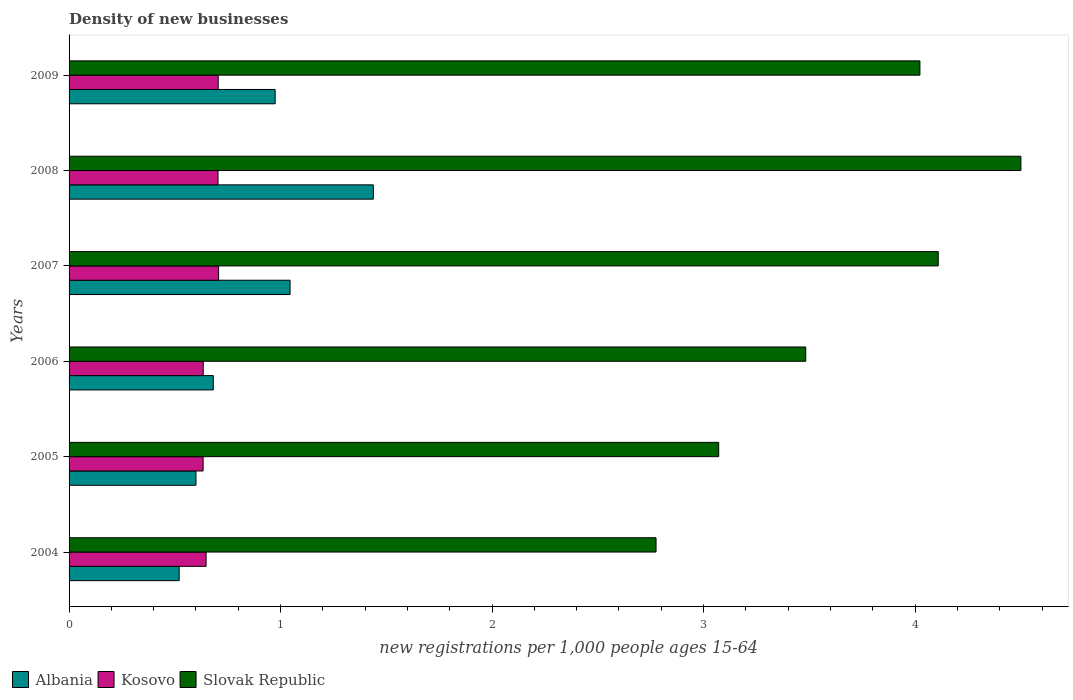How many different coloured bars are there?
Offer a very short reply. 3. How many bars are there on the 5th tick from the top?
Offer a terse response. 3. What is the label of the 4th group of bars from the top?
Offer a very short reply. 2006. In how many cases, is the number of bars for a given year not equal to the number of legend labels?
Your answer should be very brief. 0. What is the number of new registrations in Albania in 2007?
Provide a succinct answer. 1.04. Across all years, what is the maximum number of new registrations in Kosovo?
Offer a terse response. 0.71. Across all years, what is the minimum number of new registrations in Slovak Republic?
Your answer should be compact. 2.78. In which year was the number of new registrations in Albania maximum?
Provide a succinct answer. 2008. What is the total number of new registrations in Kosovo in the graph?
Ensure brevity in your answer.  4.03. What is the difference between the number of new registrations in Slovak Republic in 2004 and that in 2005?
Your answer should be compact. -0.3. What is the difference between the number of new registrations in Kosovo in 2004 and the number of new registrations in Albania in 2009?
Provide a succinct answer. -0.33. What is the average number of new registrations in Slovak Republic per year?
Provide a succinct answer. 3.66. In the year 2007, what is the difference between the number of new registrations in Albania and number of new registrations in Kosovo?
Offer a terse response. 0.34. In how many years, is the number of new registrations in Albania greater than 3 ?
Keep it short and to the point. 0. What is the ratio of the number of new registrations in Kosovo in 2005 to that in 2006?
Keep it short and to the point. 1. Is the number of new registrations in Kosovo in 2008 less than that in 2009?
Offer a very short reply. Yes. Is the difference between the number of new registrations in Albania in 2004 and 2009 greater than the difference between the number of new registrations in Kosovo in 2004 and 2009?
Your answer should be compact. No. What is the difference between the highest and the second highest number of new registrations in Albania?
Your response must be concise. 0.39. What is the difference between the highest and the lowest number of new registrations in Albania?
Your answer should be compact. 0.92. What does the 1st bar from the top in 2009 represents?
Keep it short and to the point. Slovak Republic. What does the 1st bar from the bottom in 2008 represents?
Give a very brief answer. Albania. What is the difference between two consecutive major ticks on the X-axis?
Your answer should be very brief. 1. Where does the legend appear in the graph?
Your answer should be very brief. Bottom left. How are the legend labels stacked?
Provide a short and direct response. Horizontal. What is the title of the graph?
Your response must be concise. Density of new businesses. What is the label or title of the X-axis?
Offer a very short reply. New registrations per 1,0 people ages 15-64. What is the label or title of the Y-axis?
Offer a very short reply. Years. What is the new registrations per 1,000 people ages 15-64 in Albania in 2004?
Provide a short and direct response. 0.52. What is the new registrations per 1,000 people ages 15-64 of Kosovo in 2004?
Provide a succinct answer. 0.65. What is the new registrations per 1,000 people ages 15-64 in Slovak Republic in 2004?
Ensure brevity in your answer.  2.78. What is the new registrations per 1,000 people ages 15-64 of Albania in 2005?
Keep it short and to the point. 0.6. What is the new registrations per 1,000 people ages 15-64 in Kosovo in 2005?
Your answer should be very brief. 0.63. What is the new registrations per 1,000 people ages 15-64 in Slovak Republic in 2005?
Provide a short and direct response. 3.07. What is the new registrations per 1,000 people ages 15-64 in Albania in 2006?
Provide a short and direct response. 0.68. What is the new registrations per 1,000 people ages 15-64 in Kosovo in 2006?
Your response must be concise. 0.63. What is the new registrations per 1,000 people ages 15-64 of Slovak Republic in 2006?
Your response must be concise. 3.48. What is the new registrations per 1,000 people ages 15-64 of Albania in 2007?
Provide a succinct answer. 1.04. What is the new registrations per 1,000 people ages 15-64 of Kosovo in 2007?
Your response must be concise. 0.71. What is the new registrations per 1,000 people ages 15-64 of Slovak Republic in 2007?
Provide a succinct answer. 4.11. What is the new registrations per 1,000 people ages 15-64 in Albania in 2008?
Offer a very short reply. 1.44. What is the new registrations per 1,000 people ages 15-64 in Kosovo in 2008?
Give a very brief answer. 0.7. What is the new registrations per 1,000 people ages 15-64 in Slovak Republic in 2008?
Give a very brief answer. 4.5. What is the new registrations per 1,000 people ages 15-64 of Albania in 2009?
Provide a short and direct response. 0.97. What is the new registrations per 1,000 people ages 15-64 in Kosovo in 2009?
Make the answer very short. 0.7. What is the new registrations per 1,000 people ages 15-64 of Slovak Republic in 2009?
Your answer should be compact. 4.02. Across all years, what is the maximum new registrations per 1,000 people ages 15-64 in Albania?
Make the answer very short. 1.44. Across all years, what is the maximum new registrations per 1,000 people ages 15-64 in Kosovo?
Your response must be concise. 0.71. Across all years, what is the maximum new registrations per 1,000 people ages 15-64 in Slovak Republic?
Your response must be concise. 4.5. Across all years, what is the minimum new registrations per 1,000 people ages 15-64 of Albania?
Your answer should be compact. 0.52. Across all years, what is the minimum new registrations per 1,000 people ages 15-64 of Kosovo?
Ensure brevity in your answer.  0.63. Across all years, what is the minimum new registrations per 1,000 people ages 15-64 of Slovak Republic?
Provide a short and direct response. 2.78. What is the total new registrations per 1,000 people ages 15-64 of Albania in the graph?
Your response must be concise. 5.26. What is the total new registrations per 1,000 people ages 15-64 in Kosovo in the graph?
Your answer should be compact. 4.03. What is the total new registrations per 1,000 people ages 15-64 of Slovak Republic in the graph?
Provide a succinct answer. 21.96. What is the difference between the new registrations per 1,000 people ages 15-64 of Albania in 2004 and that in 2005?
Offer a very short reply. -0.08. What is the difference between the new registrations per 1,000 people ages 15-64 of Kosovo in 2004 and that in 2005?
Ensure brevity in your answer.  0.01. What is the difference between the new registrations per 1,000 people ages 15-64 in Slovak Republic in 2004 and that in 2005?
Offer a terse response. -0.3. What is the difference between the new registrations per 1,000 people ages 15-64 in Albania in 2004 and that in 2006?
Offer a very short reply. -0.16. What is the difference between the new registrations per 1,000 people ages 15-64 in Kosovo in 2004 and that in 2006?
Ensure brevity in your answer.  0.01. What is the difference between the new registrations per 1,000 people ages 15-64 of Slovak Republic in 2004 and that in 2006?
Your answer should be compact. -0.71. What is the difference between the new registrations per 1,000 people ages 15-64 of Albania in 2004 and that in 2007?
Your answer should be compact. -0.52. What is the difference between the new registrations per 1,000 people ages 15-64 in Kosovo in 2004 and that in 2007?
Offer a terse response. -0.06. What is the difference between the new registrations per 1,000 people ages 15-64 of Slovak Republic in 2004 and that in 2007?
Provide a short and direct response. -1.33. What is the difference between the new registrations per 1,000 people ages 15-64 of Albania in 2004 and that in 2008?
Ensure brevity in your answer.  -0.92. What is the difference between the new registrations per 1,000 people ages 15-64 of Kosovo in 2004 and that in 2008?
Provide a succinct answer. -0.06. What is the difference between the new registrations per 1,000 people ages 15-64 in Slovak Republic in 2004 and that in 2008?
Your answer should be very brief. -1.73. What is the difference between the new registrations per 1,000 people ages 15-64 of Albania in 2004 and that in 2009?
Ensure brevity in your answer.  -0.45. What is the difference between the new registrations per 1,000 people ages 15-64 of Kosovo in 2004 and that in 2009?
Provide a succinct answer. -0.06. What is the difference between the new registrations per 1,000 people ages 15-64 in Slovak Republic in 2004 and that in 2009?
Offer a terse response. -1.25. What is the difference between the new registrations per 1,000 people ages 15-64 in Albania in 2005 and that in 2006?
Offer a terse response. -0.08. What is the difference between the new registrations per 1,000 people ages 15-64 in Kosovo in 2005 and that in 2006?
Ensure brevity in your answer.  -0. What is the difference between the new registrations per 1,000 people ages 15-64 of Slovak Republic in 2005 and that in 2006?
Keep it short and to the point. -0.41. What is the difference between the new registrations per 1,000 people ages 15-64 in Albania in 2005 and that in 2007?
Keep it short and to the point. -0.45. What is the difference between the new registrations per 1,000 people ages 15-64 of Kosovo in 2005 and that in 2007?
Your response must be concise. -0.07. What is the difference between the new registrations per 1,000 people ages 15-64 in Slovak Republic in 2005 and that in 2007?
Give a very brief answer. -1.04. What is the difference between the new registrations per 1,000 people ages 15-64 in Albania in 2005 and that in 2008?
Your answer should be compact. -0.84. What is the difference between the new registrations per 1,000 people ages 15-64 of Kosovo in 2005 and that in 2008?
Keep it short and to the point. -0.07. What is the difference between the new registrations per 1,000 people ages 15-64 in Slovak Republic in 2005 and that in 2008?
Ensure brevity in your answer.  -1.43. What is the difference between the new registrations per 1,000 people ages 15-64 in Albania in 2005 and that in 2009?
Keep it short and to the point. -0.37. What is the difference between the new registrations per 1,000 people ages 15-64 in Kosovo in 2005 and that in 2009?
Ensure brevity in your answer.  -0.07. What is the difference between the new registrations per 1,000 people ages 15-64 in Slovak Republic in 2005 and that in 2009?
Provide a succinct answer. -0.95. What is the difference between the new registrations per 1,000 people ages 15-64 of Albania in 2006 and that in 2007?
Offer a very short reply. -0.36. What is the difference between the new registrations per 1,000 people ages 15-64 of Kosovo in 2006 and that in 2007?
Provide a short and direct response. -0.07. What is the difference between the new registrations per 1,000 people ages 15-64 in Slovak Republic in 2006 and that in 2007?
Provide a short and direct response. -0.63. What is the difference between the new registrations per 1,000 people ages 15-64 in Albania in 2006 and that in 2008?
Ensure brevity in your answer.  -0.76. What is the difference between the new registrations per 1,000 people ages 15-64 of Kosovo in 2006 and that in 2008?
Offer a terse response. -0.07. What is the difference between the new registrations per 1,000 people ages 15-64 in Slovak Republic in 2006 and that in 2008?
Your answer should be very brief. -1.02. What is the difference between the new registrations per 1,000 people ages 15-64 in Albania in 2006 and that in 2009?
Offer a very short reply. -0.29. What is the difference between the new registrations per 1,000 people ages 15-64 of Kosovo in 2006 and that in 2009?
Your answer should be compact. -0.07. What is the difference between the new registrations per 1,000 people ages 15-64 of Slovak Republic in 2006 and that in 2009?
Make the answer very short. -0.54. What is the difference between the new registrations per 1,000 people ages 15-64 of Albania in 2007 and that in 2008?
Your answer should be compact. -0.39. What is the difference between the new registrations per 1,000 people ages 15-64 of Kosovo in 2007 and that in 2008?
Keep it short and to the point. 0. What is the difference between the new registrations per 1,000 people ages 15-64 of Slovak Republic in 2007 and that in 2008?
Ensure brevity in your answer.  -0.39. What is the difference between the new registrations per 1,000 people ages 15-64 of Albania in 2007 and that in 2009?
Keep it short and to the point. 0.07. What is the difference between the new registrations per 1,000 people ages 15-64 of Kosovo in 2007 and that in 2009?
Give a very brief answer. 0. What is the difference between the new registrations per 1,000 people ages 15-64 of Slovak Republic in 2007 and that in 2009?
Provide a succinct answer. 0.09. What is the difference between the new registrations per 1,000 people ages 15-64 in Albania in 2008 and that in 2009?
Keep it short and to the point. 0.46. What is the difference between the new registrations per 1,000 people ages 15-64 of Kosovo in 2008 and that in 2009?
Your answer should be very brief. -0. What is the difference between the new registrations per 1,000 people ages 15-64 of Slovak Republic in 2008 and that in 2009?
Provide a short and direct response. 0.48. What is the difference between the new registrations per 1,000 people ages 15-64 of Albania in 2004 and the new registrations per 1,000 people ages 15-64 of Kosovo in 2005?
Give a very brief answer. -0.11. What is the difference between the new registrations per 1,000 people ages 15-64 in Albania in 2004 and the new registrations per 1,000 people ages 15-64 in Slovak Republic in 2005?
Give a very brief answer. -2.55. What is the difference between the new registrations per 1,000 people ages 15-64 of Kosovo in 2004 and the new registrations per 1,000 people ages 15-64 of Slovak Republic in 2005?
Provide a short and direct response. -2.42. What is the difference between the new registrations per 1,000 people ages 15-64 of Albania in 2004 and the new registrations per 1,000 people ages 15-64 of Kosovo in 2006?
Make the answer very short. -0.11. What is the difference between the new registrations per 1,000 people ages 15-64 of Albania in 2004 and the new registrations per 1,000 people ages 15-64 of Slovak Republic in 2006?
Keep it short and to the point. -2.96. What is the difference between the new registrations per 1,000 people ages 15-64 in Kosovo in 2004 and the new registrations per 1,000 people ages 15-64 in Slovak Republic in 2006?
Offer a terse response. -2.84. What is the difference between the new registrations per 1,000 people ages 15-64 in Albania in 2004 and the new registrations per 1,000 people ages 15-64 in Kosovo in 2007?
Keep it short and to the point. -0.19. What is the difference between the new registrations per 1,000 people ages 15-64 of Albania in 2004 and the new registrations per 1,000 people ages 15-64 of Slovak Republic in 2007?
Your answer should be very brief. -3.59. What is the difference between the new registrations per 1,000 people ages 15-64 in Kosovo in 2004 and the new registrations per 1,000 people ages 15-64 in Slovak Republic in 2007?
Provide a short and direct response. -3.46. What is the difference between the new registrations per 1,000 people ages 15-64 in Albania in 2004 and the new registrations per 1,000 people ages 15-64 in Kosovo in 2008?
Ensure brevity in your answer.  -0.18. What is the difference between the new registrations per 1,000 people ages 15-64 in Albania in 2004 and the new registrations per 1,000 people ages 15-64 in Slovak Republic in 2008?
Your response must be concise. -3.98. What is the difference between the new registrations per 1,000 people ages 15-64 of Kosovo in 2004 and the new registrations per 1,000 people ages 15-64 of Slovak Republic in 2008?
Provide a short and direct response. -3.85. What is the difference between the new registrations per 1,000 people ages 15-64 of Albania in 2004 and the new registrations per 1,000 people ages 15-64 of Kosovo in 2009?
Keep it short and to the point. -0.18. What is the difference between the new registrations per 1,000 people ages 15-64 in Albania in 2004 and the new registrations per 1,000 people ages 15-64 in Slovak Republic in 2009?
Your response must be concise. -3.5. What is the difference between the new registrations per 1,000 people ages 15-64 of Kosovo in 2004 and the new registrations per 1,000 people ages 15-64 of Slovak Republic in 2009?
Offer a very short reply. -3.38. What is the difference between the new registrations per 1,000 people ages 15-64 in Albania in 2005 and the new registrations per 1,000 people ages 15-64 in Kosovo in 2006?
Give a very brief answer. -0.03. What is the difference between the new registrations per 1,000 people ages 15-64 of Albania in 2005 and the new registrations per 1,000 people ages 15-64 of Slovak Republic in 2006?
Make the answer very short. -2.88. What is the difference between the new registrations per 1,000 people ages 15-64 of Kosovo in 2005 and the new registrations per 1,000 people ages 15-64 of Slovak Republic in 2006?
Your answer should be compact. -2.85. What is the difference between the new registrations per 1,000 people ages 15-64 in Albania in 2005 and the new registrations per 1,000 people ages 15-64 in Kosovo in 2007?
Your answer should be very brief. -0.11. What is the difference between the new registrations per 1,000 people ages 15-64 of Albania in 2005 and the new registrations per 1,000 people ages 15-64 of Slovak Republic in 2007?
Provide a short and direct response. -3.51. What is the difference between the new registrations per 1,000 people ages 15-64 of Kosovo in 2005 and the new registrations per 1,000 people ages 15-64 of Slovak Republic in 2007?
Provide a succinct answer. -3.48. What is the difference between the new registrations per 1,000 people ages 15-64 in Albania in 2005 and the new registrations per 1,000 people ages 15-64 in Kosovo in 2008?
Offer a very short reply. -0.1. What is the difference between the new registrations per 1,000 people ages 15-64 of Albania in 2005 and the new registrations per 1,000 people ages 15-64 of Slovak Republic in 2008?
Provide a short and direct response. -3.9. What is the difference between the new registrations per 1,000 people ages 15-64 in Kosovo in 2005 and the new registrations per 1,000 people ages 15-64 in Slovak Republic in 2008?
Make the answer very short. -3.87. What is the difference between the new registrations per 1,000 people ages 15-64 of Albania in 2005 and the new registrations per 1,000 people ages 15-64 of Kosovo in 2009?
Your answer should be compact. -0.11. What is the difference between the new registrations per 1,000 people ages 15-64 in Albania in 2005 and the new registrations per 1,000 people ages 15-64 in Slovak Republic in 2009?
Your response must be concise. -3.42. What is the difference between the new registrations per 1,000 people ages 15-64 in Kosovo in 2005 and the new registrations per 1,000 people ages 15-64 in Slovak Republic in 2009?
Ensure brevity in your answer.  -3.39. What is the difference between the new registrations per 1,000 people ages 15-64 of Albania in 2006 and the new registrations per 1,000 people ages 15-64 of Kosovo in 2007?
Offer a terse response. -0.03. What is the difference between the new registrations per 1,000 people ages 15-64 in Albania in 2006 and the new registrations per 1,000 people ages 15-64 in Slovak Republic in 2007?
Provide a short and direct response. -3.43. What is the difference between the new registrations per 1,000 people ages 15-64 in Kosovo in 2006 and the new registrations per 1,000 people ages 15-64 in Slovak Republic in 2007?
Make the answer very short. -3.48. What is the difference between the new registrations per 1,000 people ages 15-64 in Albania in 2006 and the new registrations per 1,000 people ages 15-64 in Kosovo in 2008?
Provide a short and direct response. -0.02. What is the difference between the new registrations per 1,000 people ages 15-64 in Albania in 2006 and the new registrations per 1,000 people ages 15-64 in Slovak Republic in 2008?
Ensure brevity in your answer.  -3.82. What is the difference between the new registrations per 1,000 people ages 15-64 in Kosovo in 2006 and the new registrations per 1,000 people ages 15-64 in Slovak Republic in 2008?
Your answer should be very brief. -3.87. What is the difference between the new registrations per 1,000 people ages 15-64 of Albania in 2006 and the new registrations per 1,000 people ages 15-64 of Kosovo in 2009?
Provide a short and direct response. -0.02. What is the difference between the new registrations per 1,000 people ages 15-64 of Albania in 2006 and the new registrations per 1,000 people ages 15-64 of Slovak Republic in 2009?
Your response must be concise. -3.34. What is the difference between the new registrations per 1,000 people ages 15-64 in Kosovo in 2006 and the new registrations per 1,000 people ages 15-64 in Slovak Republic in 2009?
Provide a short and direct response. -3.39. What is the difference between the new registrations per 1,000 people ages 15-64 in Albania in 2007 and the new registrations per 1,000 people ages 15-64 in Kosovo in 2008?
Give a very brief answer. 0.34. What is the difference between the new registrations per 1,000 people ages 15-64 of Albania in 2007 and the new registrations per 1,000 people ages 15-64 of Slovak Republic in 2008?
Provide a succinct answer. -3.46. What is the difference between the new registrations per 1,000 people ages 15-64 in Kosovo in 2007 and the new registrations per 1,000 people ages 15-64 in Slovak Republic in 2008?
Your answer should be compact. -3.79. What is the difference between the new registrations per 1,000 people ages 15-64 in Albania in 2007 and the new registrations per 1,000 people ages 15-64 in Kosovo in 2009?
Ensure brevity in your answer.  0.34. What is the difference between the new registrations per 1,000 people ages 15-64 of Albania in 2007 and the new registrations per 1,000 people ages 15-64 of Slovak Republic in 2009?
Provide a short and direct response. -2.98. What is the difference between the new registrations per 1,000 people ages 15-64 in Kosovo in 2007 and the new registrations per 1,000 people ages 15-64 in Slovak Republic in 2009?
Give a very brief answer. -3.32. What is the difference between the new registrations per 1,000 people ages 15-64 of Albania in 2008 and the new registrations per 1,000 people ages 15-64 of Kosovo in 2009?
Provide a succinct answer. 0.73. What is the difference between the new registrations per 1,000 people ages 15-64 in Albania in 2008 and the new registrations per 1,000 people ages 15-64 in Slovak Republic in 2009?
Provide a succinct answer. -2.58. What is the difference between the new registrations per 1,000 people ages 15-64 in Kosovo in 2008 and the new registrations per 1,000 people ages 15-64 in Slovak Republic in 2009?
Provide a succinct answer. -3.32. What is the average new registrations per 1,000 people ages 15-64 of Albania per year?
Your answer should be very brief. 0.88. What is the average new registrations per 1,000 people ages 15-64 of Kosovo per year?
Keep it short and to the point. 0.67. What is the average new registrations per 1,000 people ages 15-64 in Slovak Republic per year?
Give a very brief answer. 3.66. In the year 2004, what is the difference between the new registrations per 1,000 people ages 15-64 in Albania and new registrations per 1,000 people ages 15-64 in Kosovo?
Provide a succinct answer. -0.13. In the year 2004, what is the difference between the new registrations per 1,000 people ages 15-64 in Albania and new registrations per 1,000 people ages 15-64 in Slovak Republic?
Your answer should be very brief. -2.25. In the year 2004, what is the difference between the new registrations per 1,000 people ages 15-64 of Kosovo and new registrations per 1,000 people ages 15-64 of Slovak Republic?
Your response must be concise. -2.13. In the year 2005, what is the difference between the new registrations per 1,000 people ages 15-64 in Albania and new registrations per 1,000 people ages 15-64 in Kosovo?
Your response must be concise. -0.03. In the year 2005, what is the difference between the new registrations per 1,000 people ages 15-64 of Albania and new registrations per 1,000 people ages 15-64 of Slovak Republic?
Offer a very short reply. -2.47. In the year 2005, what is the difference between the new registrations per 1,000 people ages 15-64 of Kosovo and new registrations per 1,000 people ages 15-64 of Slovak Republic?
Ensure brevity in your answer.  -2.44. In the year 2006, what is the difference between the new registrations per 1,000 people ages 15-64 of Albania and new registrations per 1,000 people ages 15-64 of Kosovo?
Provide a short and direct response. 0.05. In the year 2006, what is the difference between the new registrations per 1,000 people ages 15-64 in Albania and new registrations per 1,000 people ages 15-64 in Slovak Republic?
Offer a terse response. -2.8. In the year 2006, what is the difference between the new registrations per 1,000 people ages 15-64 in Kosovo and new registrations per 1,000 people ages 15-64 in Slovak Republic?
Your answer should be compact. -2.85. In the year 2007, what is the difference between the new registrations per 1,000 people ages 15-64 in Albania and new registrations per 1,000 people ages 15-64 in Kosovo?
Provide a short and direct response. 0.34. In the year 2007, what is the difference between the new registrations per 1,000 people ages 15-64 in Albania and new registrations per 1,000 people ages 15-64 in Slovak Republic?
Ensure brevity in your answer.  -3.06. In the year 2007, what is the difference between the new registrations per 1,000 people ages 15-64 in Kosovo and new registrations per 1,000 people ages 15-64 in Slovak Republic?
Provide a succinct answer. -3.4. In the year 2008, what is the difference between the new registrations per 1,000 people ages 15-64 in Albania and new registrations per 1,000 people ages 15-64 in Kosovo?
Provide a short and direct response. 0.73. In the year 2008, what is the difference between the new registrations per 1,000 people ages 15-64 in Albania and new registrations per 1,000 people ages 15-64 in Slovak Republic?
Your answer should be compact. -3.06. In the year 2008, what is the difference between the new registrations per 1,000 people ages 15-64 in Kosovo and new registrations per 1,000 people ages 15-64 in Slovak Republic?
Give a very brief answer. -3.8. In the year 2009, what is the difference between the new registrations per 1,000 people ages 15-64 of Albania and new registrations per 1,000 people ages 15-64 of Kosovo?
Offer a very short reply. 0.27. In the year 2009, what is the difference between the new registrations per 1,000 people ages 15-64 of Albania and new registrations per 1,000 people ages 15-64 of Slovak Republic?
Make the answer very short. -3.05. In the year 2009, what is the difference between the new registrations per 1,000 people ages 15-64 of Kosovo and new registrations per 1,000 people ages 15-64 of Slovak Republic?
Offer a very short reply. -3.32. What is the ratio of the new registrations per 1,000 people ages 15-64 in Albania in 2004 to that in 2005?
Your answer should be very brief. 0.87. What is the ratio of the new registrations per 1,000 people ages 15-64 in Kosovo in 2004 to that in 2005?
Offer a terse response. 1.02. What is the ratio of the new registrations per 1,000 people ages 15-64 of Slovak Republic in 2004 to that in 2005?
Your answer should be compact. 0.9. What is the ratio of the new registrations per 1,000 people ages 15-64 in Albania in 2004 to that in 2006?
Provide a succinct answer. 0.76. What is the ratio of the new registrations per 1,000 people ages 15-64 in Kosovo in 2004 to that in 2006?
Your answer should be very brief. 1.02. What is the ratio of the new registrations per 1,000 people ages 15-64 in Slovak Republic in 2004 to that in 2006?
Provide a succinct answer. 0.8. What is the ratio of the new registrations per 1,000 people ages 15-64 of Albania in 2004 to that in 2007?
Provide a short and direct response. 0.5. What is the ratio of the new registrations per 1,000 people ages 15-64 of Kosovo in 2004 to that in 2007?
Your answer should be very brief. 0.92. What is the ratio of the new registrations per 1,000 people ages 15-64 of Slovak Republic in 2004 to that in 2007?
Keep it short and to the point. 0.68. What is the ratio of the new registrations per 1,000 people ages 15-64 in Albania in 2004 to that in 2008?
Give a very brief answer. 0.36. What is the ratio of the new registrations per 1,000 people ages 15-64 of Kosovo in 2004 to that in 2008?
Your answer should be compact. 0.92. What is the ratio of the new registrations per 1,000 people ages 15-64 in Slovak Republic in 2004 to that in 2008?
Your answer should be compact. 0.62. What is the ratio of the new registrations per 1,000 people ages 15-64 in Albania in 2004 to that in 2009?
Make the answer very short. 0.53. What is the ratio of the new registrations per 1,000 people ages 15-64 in Kosovo in 2004 to that in 2009?
Give a very brief answer. 0.92. What is the ratio of the new registrations per 1,000 people ages 15-64 in Slovak Republic in 2004 to that in 2009?
Make the answer very short. 0.69. What is the ratio of the new registrations per 1,000 people ages 15-64 of Albania in 2005 to that in 2006?
Your answer should be compact. 0.88. What is the ratio of the new registrations per 1,000 people ages 15-64 in Kosovo in 2005 to that in 2006?
Offer a very short reply. 1. What is the ratio of the new registrations per 1,000 people ages 15-64 of Slovak Republic in 2005 to that in 2006?
Provide a succinct answer. 0.88. What is the ratio of the new registrations per 1,000 people ages 15-64 in Albania in 2005 to that in 2007?
Your response must be concise. 0.57. What is the ratio of the new registrations per 1,000 people ages 15-64 of Kosovo in 2005 to that in 2007?
Make the answer very short. 0.9. What is the ratio of the new registrations per 1,000 people ages 15-64 in Slovak Republic in 2005 to that in 2007?
Keep it short and to the point. 0.75. What is the ratio of the new registrations per 1,000 people ages 15-64 of Albania in 2005 to that in 2008?
Give a very brief answer. 0.42. What is the ratio of the new registrations per 1,000 people ages 15-64 in Kosovo in 2005 to that in 2008?
Make the answer very short. 0.9. What is the ratio of the new registrations per 1,000 people ages 15-64 of Slovak Republic in 2005 to that in 2008?
Your response must be concise. 0.68. What is the ratio of the new registrations per 1,000 people ages 15-64 in Albania in 2005 to that in 2009?
Provide a succinct answer. 0.62. What is the ratio of the new registrations per 1,000 people ages 15-64 in Kosovo in 2005 to that in 2009?
Give a very brief answer. 0.9. What is the ratio of the new registrations per 1,000 people ages 15-64 of Slovak Republic in 2005 to that in 2009?
Your answer should be very brief. 0.76. What is the ratio of the new registrations per 1,000 people ages 15-64 of Albania in 2006 to that in 2007?
Keep it short and to the point. 0.65. What is the ratio of the new registrations per 1,000 people ages 15-64 of Kosovo in 2006 to that in 2007?
Offer a terse response. 0.9. What is the ratio of the new registrations per 1,000 people ages 15-64 of Slovak Republic in 2006 to that in 2007?
Offer a terse response. 0.85. What is the ratio of the new registrations per 1,000 people ages 15-64 in Albania in 2006 to that in 2008?
Provide a succinct answer. 0.47. What is the ratio of the new registrations per 1,000 people ages 15-64 in Kosovo in 2006 to that in 2008?
Offer a terse response. 0.9. What is the ratio of the new registrations per 1,000 people ages 15-64 in Slovak Republic in 2006 to that in 2008?
Offer a terse response. 0.77. What is the ratio of the new registrations per 1,000 people ages 15-64 of Albania in 2006 to that in 2009?
Your answer should be compact. 0.7. What is the ratio of the new registrations per 1,000 people ages 15-64 in Kosovo in 2006 to that in 2009?
Provide a succinct answer. 0.9. What is the ratio of the new registrations per 1,000 people ages 15-64 in Slovak Republic in 2006 to that in 2009?
Provide a short and direct response. 0.87. What is the ratio of the new registrations per 1,000 people ages 15-64 of Albania in 2007 to that in 2008?
Provide a short and direct response. 0.73. What is the ratio of the new registrations per 1,000 people ages 15-64 in Kosovo in 2007 to that in 2008?
Ensure brevity in your answer.  1. What is the ratio of the new registrations per 1,000 people ages 15-64 in Slovak Republic in 2007 to that in 2008?
Make the answer very short. 0.91. What is the ratio of the new registrations per 1,000 people ages 15-64 in Albania in 2007 to that in 2009?
Keep it short and to the point. 1.07. What is the ratio of the new registrations per 1,000 people ages 15-64 of Kosovo in 2007 to that in 2009?
Give a very brief answer. 1. What is the ratio of the new registrations per 1,000 people ages 15-64 of Slovak Republic in 2007 to that in 2009?
Give a very brief answer. 1.02. What is the ratio of the new registrations per 1,000 people ages 15-64 in Albania in 2008 to that in 2009?
Your response must be concise. 1.48. What is the ratio of the new registrations per 1,000 people ages 15-64 in Kosovo in 2008 to that in 2009?
Make the answer very short. 1. What is the ratio of the new registrations per 1,000 people ages 15-64 of Slovak Republic in 2008 to that in 2009?
Your response must be concise. 1.12. What is the difference between the highest and the second highest new registrations per 1,000 people ages 15-64 in Albania?
Offer a very short reply. 0.39. What is the difference between the highest and the second highest new registrations per 1,000 people ages 15-64 of Kosovo?
Offer a very short reply. 0. What is the difference between the highest and the second highest new registrations per 1,000 people ages 15-64 of Slovak Republic?
Ensure brevity in your answer.  0.39. What is the difference between the highest and the lowest new registrations per 1,000 people ages 15-64 of Albania?
Provide a succinct answer. 0.92. What is the difference between the highest and the lowest new registrations per 1,000 people ages 15-64 in Kosovo?
Keep it short and to the point. 0.07. What is the difference between the highest and the lowest new registrations per 1,000 people ages 15-64 in Slovak Republic?
Your answer should be very brief. 1.73. 